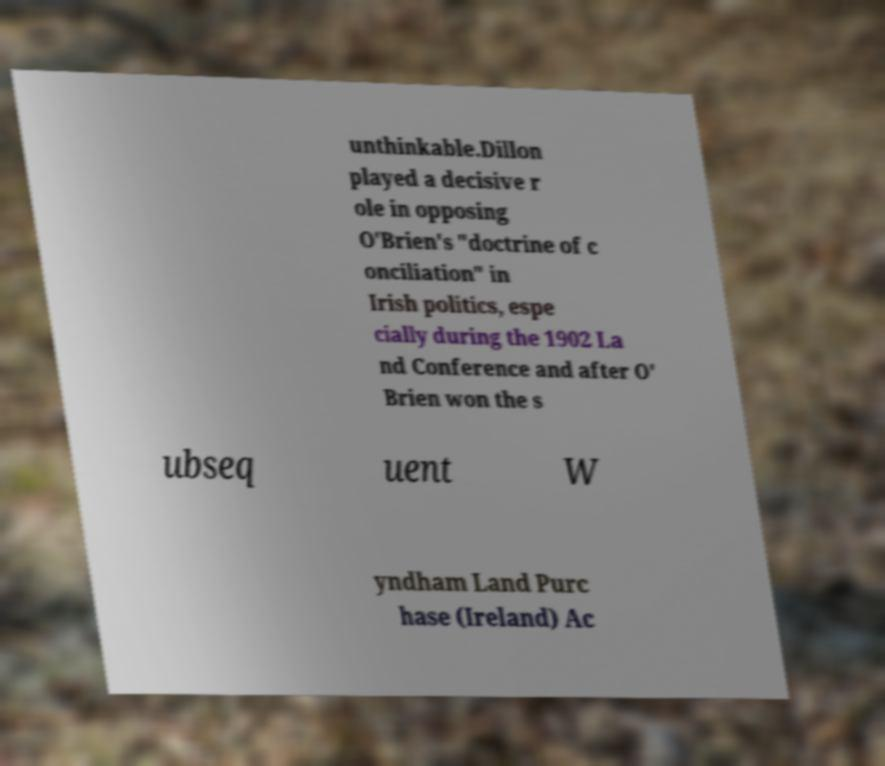Could you assist in decoding the text presented in this image and type it out clearly? unthinkable.Dillon played a decisive r ole in opposing O'Brien's "doctrine of c onciliation" in Irish politics, espe cially during the 1902 La nd Conference and after O' Brien won the s ubseq uent W yndham Land Purc hase (Ireland) Ac 